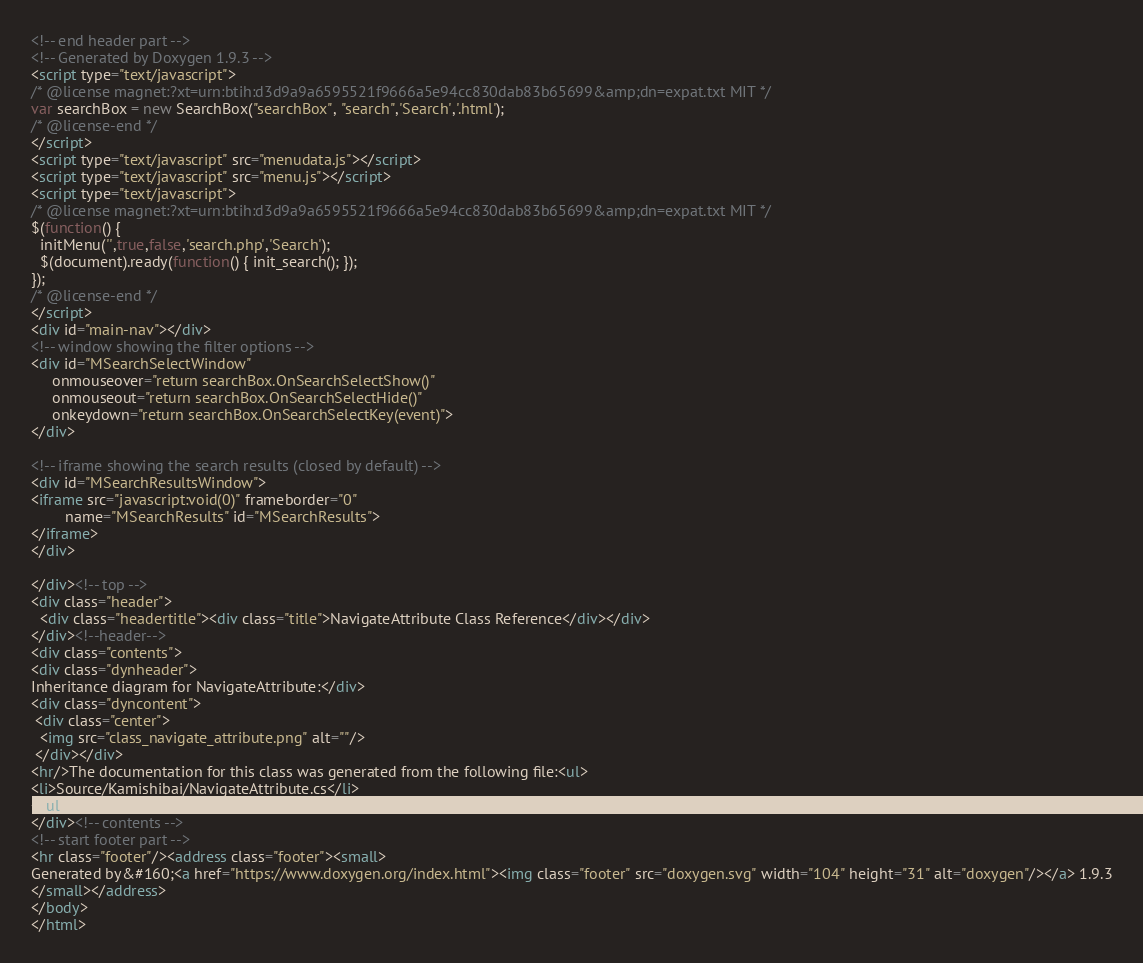<code> <loc_0><loc_0><loc_500><loc_500><_HTML_><!-- end header part -->
<!-- Generated by Doxygen 1.9.3 -->
<script type="text/javascript">
/* @license magnet:?xt=urn:btih:d3d9a9a6595521f9666a5e94cc830dab83b65699&amp;dn=expat.txt MIT */
var searchBox = new SearchBox("searchBox", "search",'Search','.html');
/* @license-end */
</script>
<script type="text/javascript" src="menudata.js"></script>
<script type="text/javascript" src="menu.js"></script>
<script type="text/javascript">
/* @license magnet:?xt=urn:btih:d3d9a9a6595521f9666a5e94cc830dab83b65699&amp;dn=expat.txt MIT */
$(function() {
  initMenu('',true,false,'search.php','Search');
  $(document).ready(function() { init_search(); });
});
/* @license-end */
</script>
<div id="main-nav"></div>
<!-- window showing the filter options -->
<div id="MSearchSelectWindow"
     onmouseover="return searchBox.OnSearchSelectShow()"
     onmouseout="return searchBox.OnSearchSelectHide()"
     onkeydown="return searchBox.OnSearchSelectKey(event)">
</div>

<!-- iframe showing the search results (closed by default) -->
<div id="MSearchResultsWindow">
<iframe src="javascript:void(0)" frameborder="0" 
        name="MSearchResults" id="MSearchResults">
</iframe>
</div>

</div><!-- top -->
<div class="header">
  <div class="headertitle"><div class="title">NavigateAttribute Class Reference</div></div>
</div><!--header-->
<div class="contents">
<div class="dynheader">
Inheritance diagram for NavigateAttribute:</div>
<div class="dyncontent">
 <div class="center">
  <img src="class_navigate_attribute.png" alt=""/>
 </div></div>
<hr/>The documentation for this class was generated from the following file:<ul>
<li>Source/Kamishibai/NavigateAttribute.cs</li>
</ul>
</div><!-- contents -->
<!-- start footer part -->
<hr class="footer"/><address class="footer"><small>
Generated by&#160;<a href="https://www.doxygen.org/index.html"><img class="footer" src="doxygen.svg" width="104" height="31" alt="doxygen"/></a> 1.9.3
</small></address>
</body>
</html>
</code> 